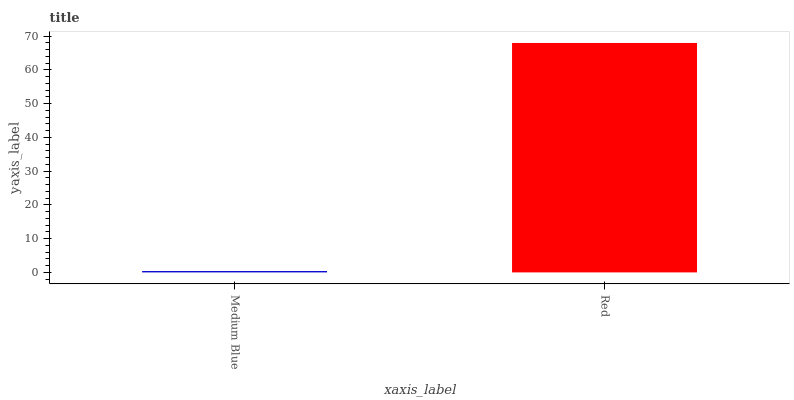Is Medium Blue the minimum?
Answer yes or no. Yes. Is Red the maximum?
Answer yes or no. Yes. Is Red the minimum?
Answer yes or no. No. Is Red greater than Medium Blue?
Answer yes or no. Yes. Is Medium Blue less than Red?
Answer yes or no. Yes. Is Medium Blue greater than Red?
Answer yes or no. No. Is Red less than Medium Blue?
Answer yes or no. No. Is Red the high median?
Answer yes or no. Yes. Is Medium Blue the low median?
Answer yes or no. Yes. Is Medium Blue the high median?
Answer yes or no. No. Is Red the low median?
Answer yes or no. No. 